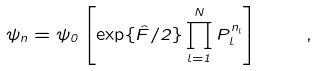<formula> <loc_0><loc_0><loc_500><loc_500>\psi _ { n } = \psi _ { 0 } \left [ \exp \{ \hat { F } / 2 \} \prod _ { l = 1 } ^ { N } P _ { l } ^ { n _ { l } } \right ] \quad ,</formula> 